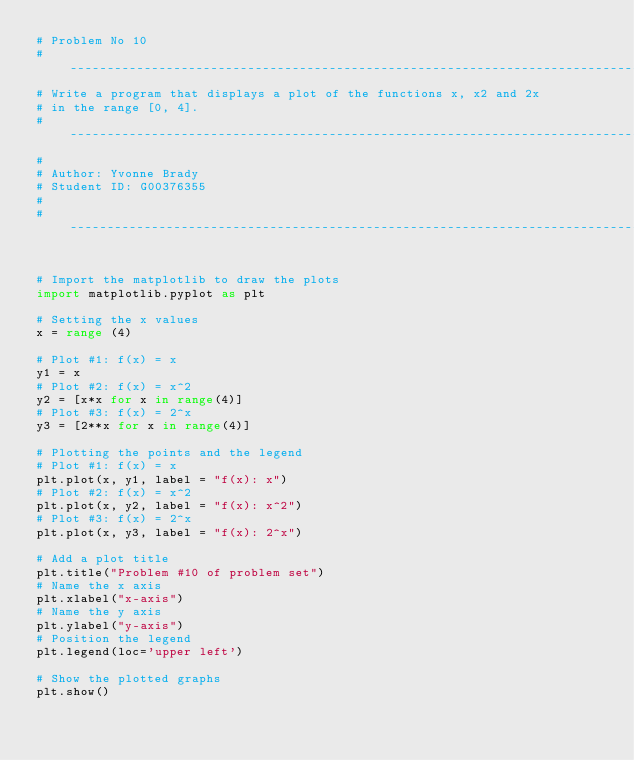Convert code to text. <code><loc_0><loc_0><loc_500><loc_500><_Python_># Problem No 10
# --------------------------------------------------------------------------------
# Write a program that displays a plot of the functions x, x2 and 2x 
# in the range [0, 4].
# --------------------------------------------------------------------------------
#
# Author: Yvonne Brady
# Student ID: G00376355
#
# --------------------------------------------------------------------------------


# Import the matplotlib to draw the plots 
import matplotlib.pyplot as plt 

# Setting the x values 
x = range (4)

# Plot #1: f(x) = x
y1 = x
# Plot #2: f(x) = x^2
y2 = [x*x for x in range(4)]
# Plot #3: f(x) = 2^x
y3 = [2**x for x in range(4)]

# Plotting the points and the legend 
# Plot #1: f(x) = x
plt.plot(x, y1, label = "f(x): x")
# Plot #2: f(x) = x^2
plt.plot(x, y2, label = "f(x): x^2")
# Plot #3: f(x) = 2^x
plt.plot(x, y3, label = "f(x): 2^x") 

# Add a plot title
plt.title("Problem #10 of problem set")
# Name the x axis
plt.xlabel("x-axis")
# Name the y axis
plt.ylabel("y-axis")
# Position the legend
plt.legend(loc='upper left')

# Show the plotted graphs 
plt.show() </code> 